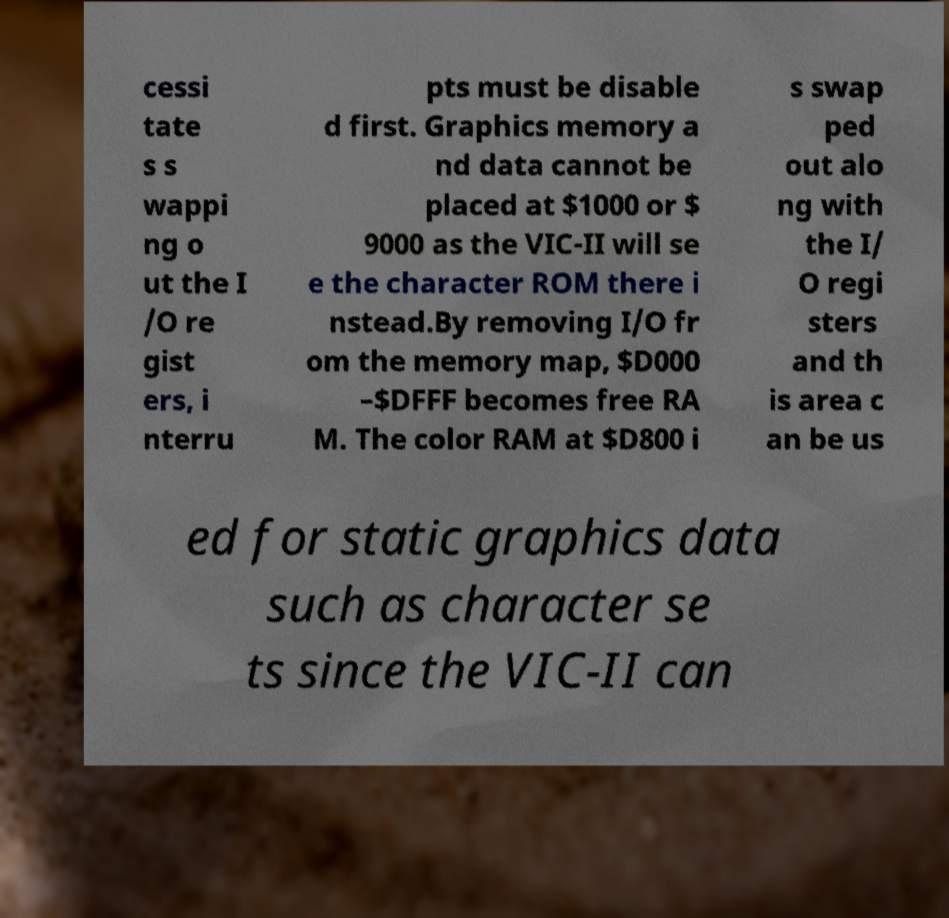Please identify and transcribe the text found in this image. cessi tate s s wappi ng o ut the I /O re gist ers, i nterru pts must be disable d first. Graphics memory a nd data cannot be placed at $1000 or $ 9000 as the VIC-II will se e the character ROM there i nstead.By removing I/O fr om the memory map, $D000 –$DFFF becomes free RA M. The color RAM at $D800 i s swap ped out alo ng with the I/ O regi sters and th is area c an be us ed for static graphics data such as character se ts since the VIC-II can 